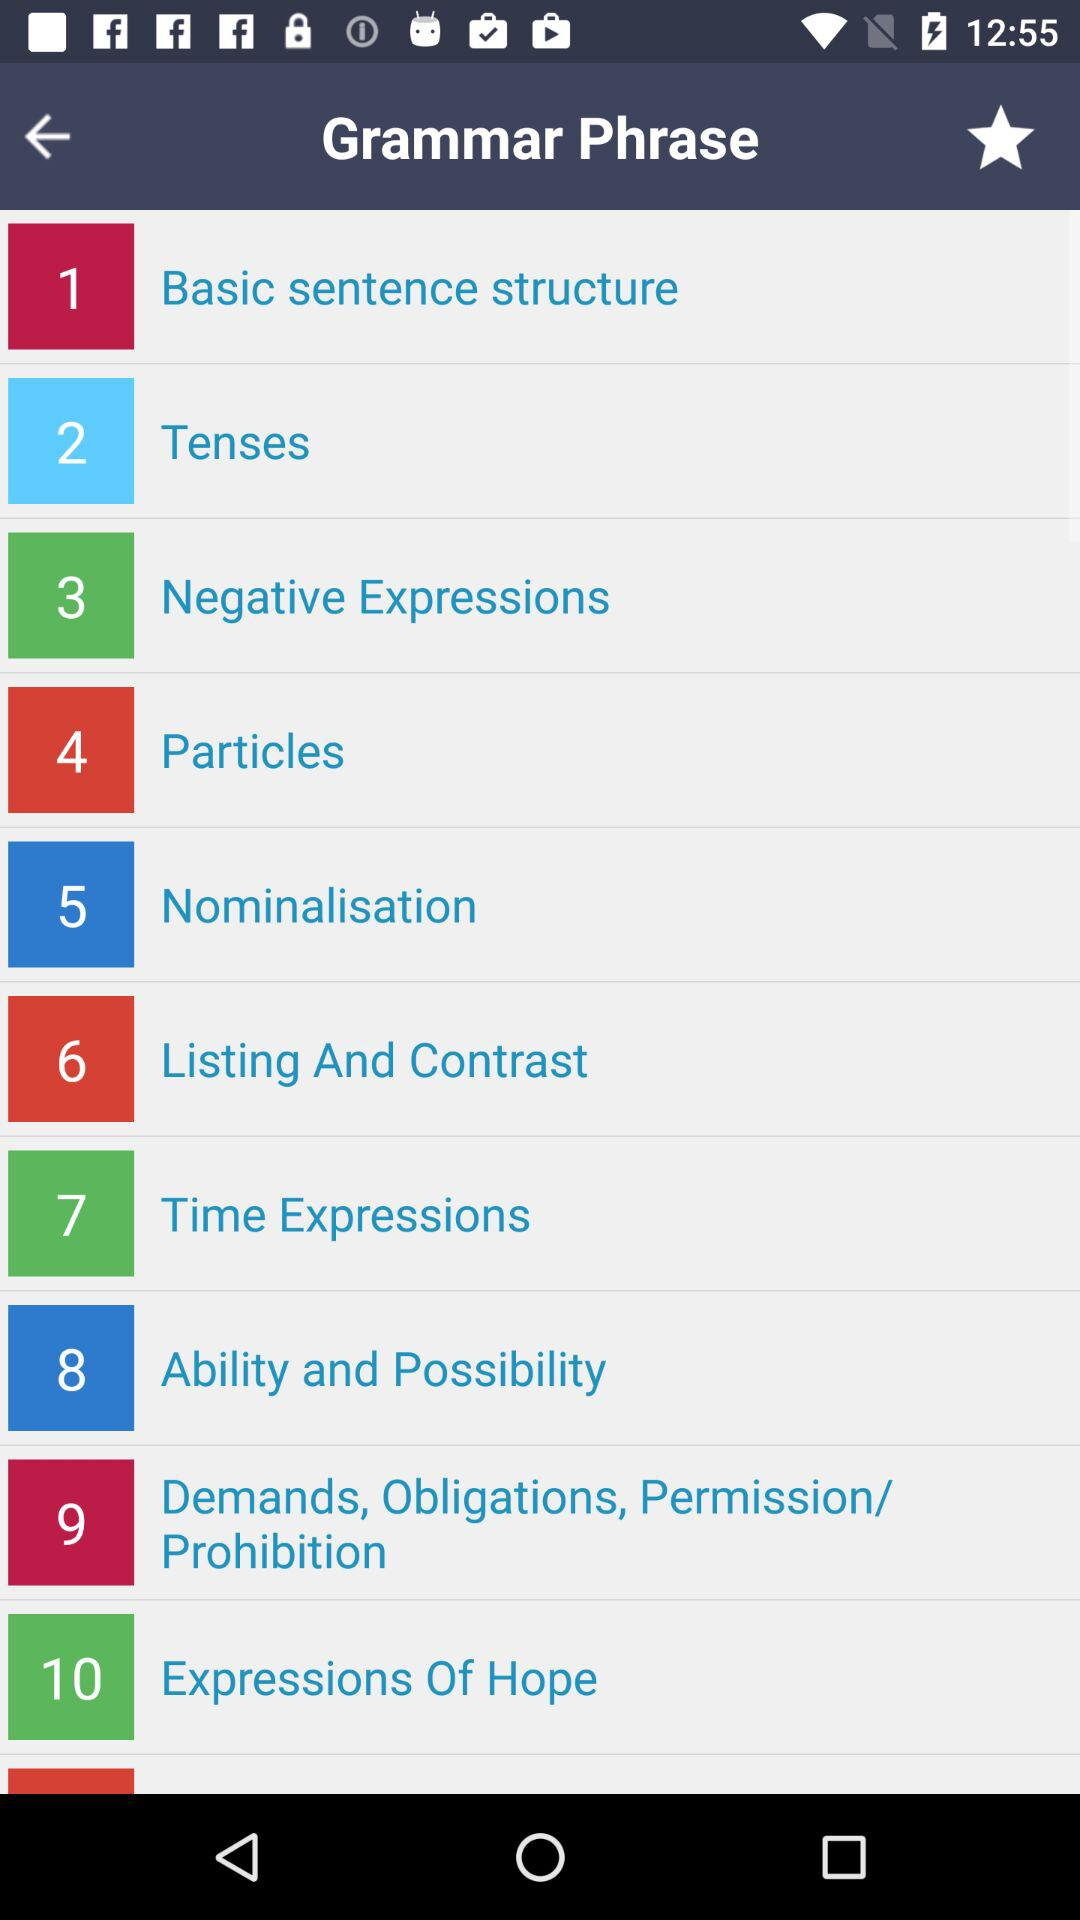What is the application name?
When the provided information is insufficient, respond with <no answer>. <no answer> 